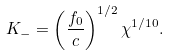Convert formula to latex. <formula><loc_0><loc_0><loc_500><loc_500>K _ { - } = \left ( \frac { f _ { 0 } } { c } \right ) ^ { 1 / 2 } \chi ^ { 1 / 1 0 } .</formula> 